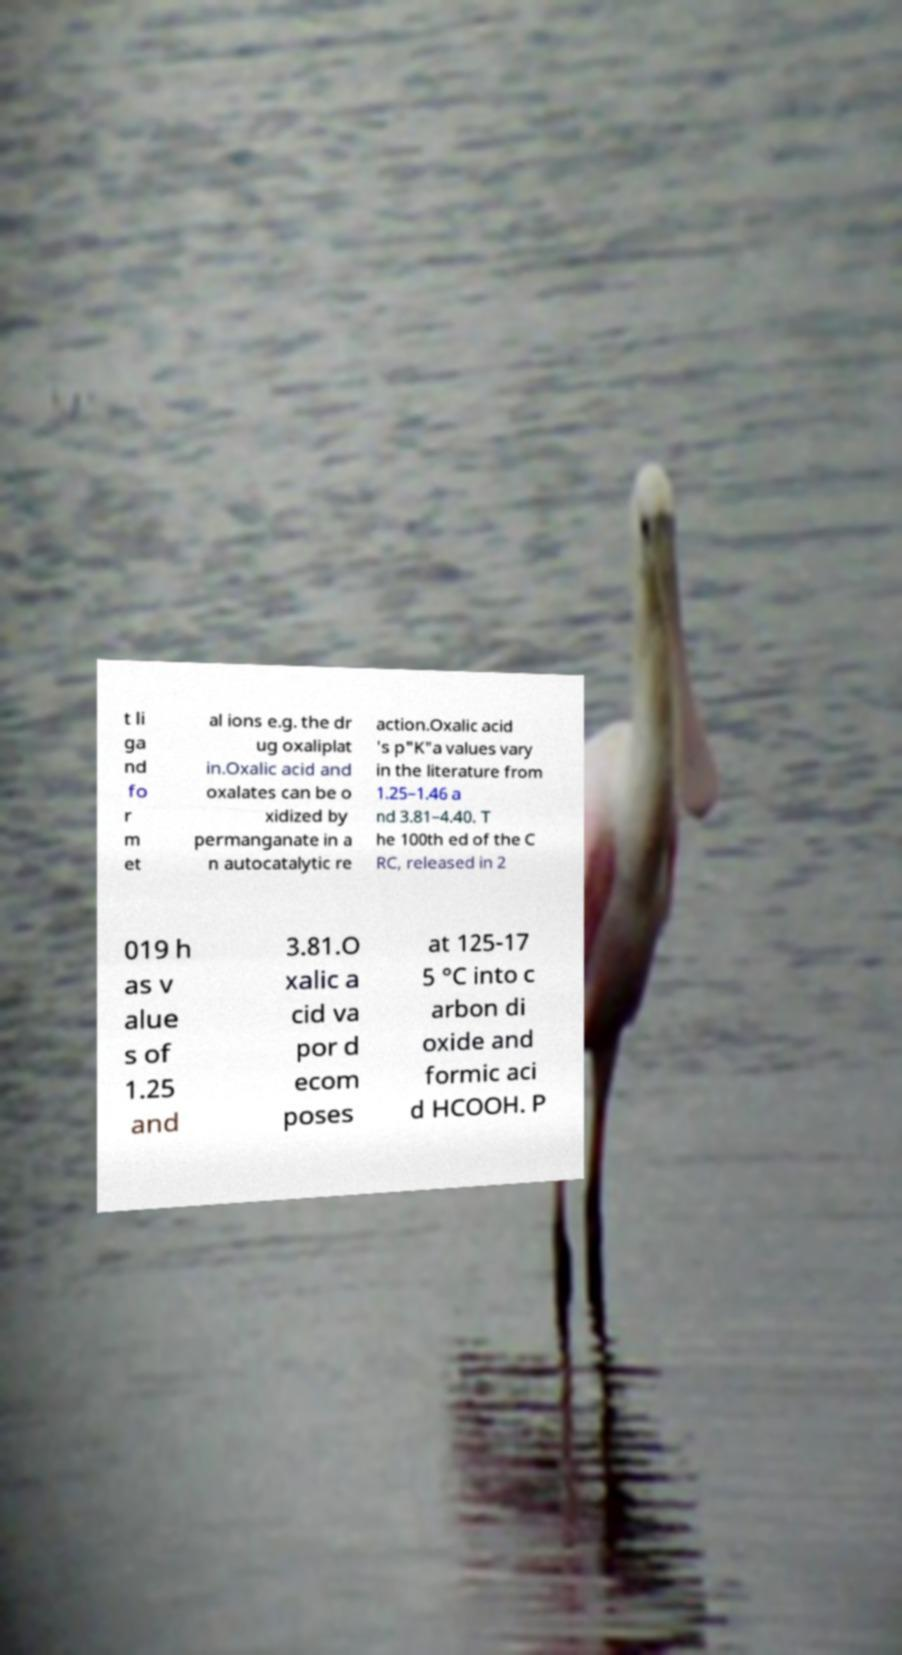I need the written content from this picture converted into text. Can you do that? t li ga nd fo r m et al ions e.g. the dr ug oxaliplat in.Oxalic acid and oxalates can be o xidized by permanganate in a n autocatalytic re action.Oxalic acid 's p"K"a values vary in the literature from 1.25–1.46 a nd 3.81–4.40. T he 100th ed of the C RC, released in 2 019 h as v alue s of 1.25 and 3.81.O xalic a cid va por d ecom poses at 125-17 5 °C into c arbon di oxide and formic aci d HCOOH. P 